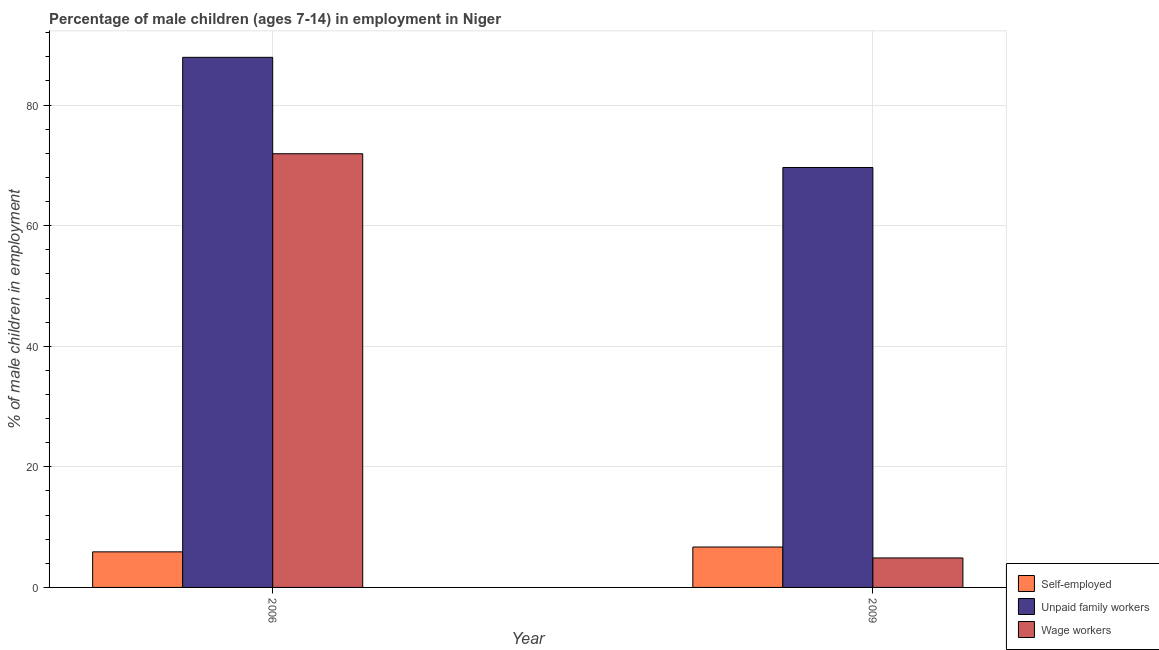How many different coloured bars are there?
Your response must be concise. 3. Are the number of bars per tick equal to the number of legend labels?
Offer a terse response. Yes. Are the number of bars on each tick of the X-axis equal?
Your answer should be very brief. Yes. How many bars are there on the 1st tick from the left?
Your answer should be compact. 3. How many bars are there on the 1st tick from the right?
Your answer should be very brief. 3. What is the label of the 2nd group of bars from the left?
Your answer should be compact. 2009. In how many cases, is the number of bars for a given year not equal to the number of legend labels?
Provide a succinct answer. 0. What is the percentage of children employed as wage workers in 2006?
Your response must be concise. 71.93. Across all years, what is the maximum percentage of self employed children?
Ensure brevity in your answer.  6.7. Across all years, what is the minimum percentage of children employed as unpaid family workers?
Offer a terse response. 69.65. In which year was the percentage of children employed as wage workers maximum?
Provide a short and direct response. 2006. What is the total percentage of children employed as unpaid family workers in the graph?
Your answer should be compact. 157.57. What is the difference between the percentage of children employed as wage workers in 2006 and that in 2009?
Ensure brevity in your answer.  67.04. What is the difference between the percentage of children employed as unpaid family workers in 2006 and the percentage of self employed children in 2009?
Ensure brevity in your answer.  18.27. What is the average percentage of children employed as wage workers per year?
Provide a short and direct response. 38.41. What is the ratio of the percentage of children employed as unpaid family workers in 2006 to that in 2009?
Your response must be concise. 1.26. What does the 2nd bar from the left in 2009 represents?
Provide a succinct answer. Unpaid family workers. What does the 2nd bar from the right in 2009 represents?
Offer a terse response. Unpaid family workers. Is it the case that in every year, the sum of the percentage of self employed children and percentage of children employed as unpaid family workers is greater than the percentage of children employed as wage workers?
Your answer should be very brief. Yes. How many years are there in the graph?
Offer a very short reply. 2. What is the difference between two consecutive major ticks on the Y-axis?
Provide a short and direct response. 20. Does the graph contain grids?
Offer a terse response. Yes. Where does the legend appear in the graph?
Provide a short and direct response. Bottom right. What is the title of the graph?
Keep it short and to the point. Percentage of male children (ages 7-14) in employment in Niger. Does "Profit Tax" appear as one of the legend labels in the graph?
Provide a short and direct response. No. What is the label or title of the Y-axis?
Offer a very short reply. % of male children in employment. What is the % of male children in employment of Self-employed in 2006?
Provide a short and direct response. 5.9. What is the % of male children in employment of Unpaid family workers in 2006?
Ensure brevity in your answer.  87.92. What is the % of male children in employment of Wage workers in 2006?
Give a very brief answer. 71.93. What is the % of male children in employment in Unpaid family workers in 2009?
Your answer should be very brief. 69.65. What is the % of male children in employment of Wage workers in 2009?
Ensure brevity in your answer.  4.89. Across all years, what is the maximum % of male children in employment of Unpaid family workers?
Keep it short and to the point. 87.92. Across all years, what is the maximum % of male children in employment in Wage workers?
Your answer should be compact. 71.93. Across all years, what is the minimum % of male children in employment in Self-employed?
Give a very brief answer. 5.9. Across all years, what is the minimum % of male children in employment in Unpaid family workers?
Give a very brief answer. 69.65. Across all years, what is the minimum % of male children in employment of Wage workers?
Keep it short and to the point. 4.89. What is the total % of male children in employment of Self-employed in the graph?
Your answer should be compact. 12.6. What is the total % of male children in employment in Unpaid family workers in the graph?
Offer a terse response. 157.57. What is the total % of male children in employment in Wage workers in the graph?
Offer a terse response. 76.82. What is the difference between the % of male children in employment of Unpaid family workers in 2006 and that in 2009?
Make the answer very short. 18.27. What is the difference between the % of male children in employment of Wage workers in 2006 and that in 2009?
Your answer should be very brief. 67.04. What is the difference between the % of male children in employment of Self-employed in 2006 and the % of male children in employment of Unpaid family workers in 2009?
Your response must be concise. -63.75. What is the difference between the % of male children in employment of Unpaid family workers in 2006 and the % of male children in employment of Wage workers in 2009?
Your answer should be very brief. 83.03. What is the average % of male children in employment in Self-employed per year?
Ensure brevity in your answer.  6.3. What is the average % of male children in employment of Unpaid family workers per year?
Ensure brevity in your answer.  78.78. What is the average % of male children in employment in Wage workers per year?
Offer a terse response. 38.41. In the year 2006, what is the difference between the % of male children in employment in Self-employed and % of male children in employment in Unpaid family workers?
Your response must be concise. -82.02. In the year 2006, what is the difference between the % of male children in employment in Self-employed and % of male children in employment in Wage workers?
Offer a terse response. -66.03. In the year 2006, what is the difference between the % of male children in employment of Unpaid family workers and % of male children in employment of Wage workers?
Ensure brevity in your answer.  15.99. In the year 2009, what is the difference between the % of male children in employment of Self-employed and % of male children in employment of Unpaid family workers?
Provide a short and direct response. -62.95. In the year 2009, what is the difference between the % of male children in employment of Self-employed and % of male children in employment of Wage workers?
Provide a short and direct response. 1.81. In the year 2009, what is the difference between the % of male children in employment of Unpaid family workers and % of male children in employment of Wage workers?
Make the answer very short. 64.76. What is the ratio of the % of male children in employment of Self-employed in 2006 to that in 2009?
Your answer should be compact. 0.88. What is the ratio of the % of male children in employment in Unpaid family workers in 2006 to that in 2009?
Offer a terse response. 1.26. What is the ratio of the % of male children in employment of Wage workers in 2006 to that in 2009?
Your answer should be very brief. 14.71. What is the difference between the highest and the second highest % of male children in employment of Unpaid family workers?
Your answer should be compact. 18.27. What is the difference between the highest and the second highest % of male children in employment of Wage workers?
Give a very brief answer. 67.04. What is the difference between the highest and the lowest % of male children in employment of Self-employed?
Your answer should be compact. 0.8. What is the difference between the highest and the lowest % of male children in employment in Unpaid family workers?
Ensure brevity in your answer.  18.27. What is the difference between the highest and the lowest % of male children in employment of Wage workers?
Give a very brief answer. 67.04. 